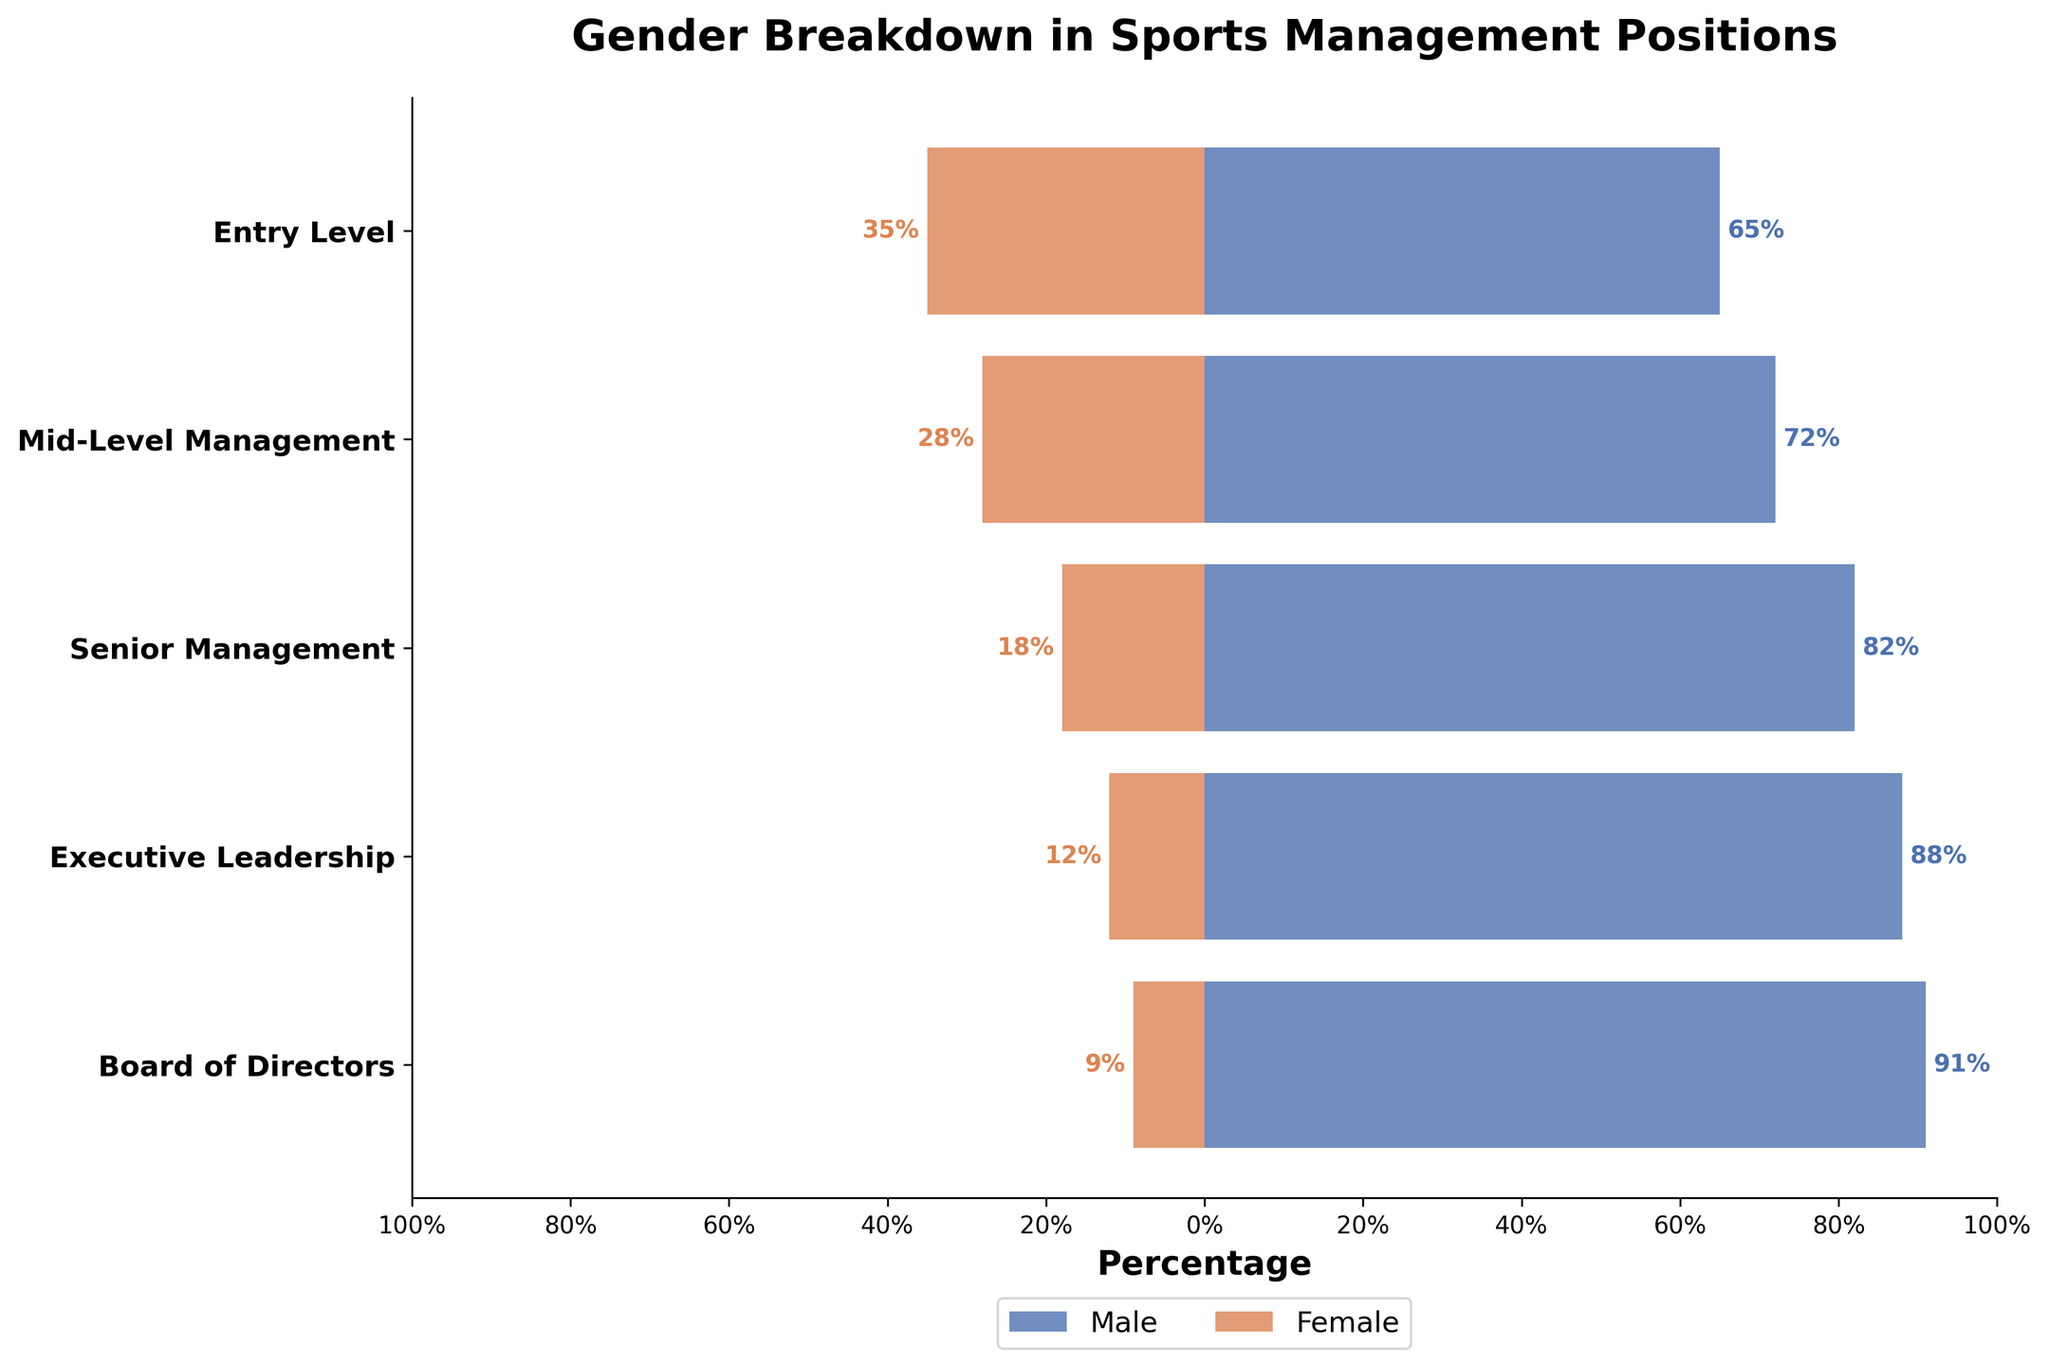what is the title of the plot? The title is usually located at the top of the plot and generally describes what the figure is about. Here, it states the theme of the plot clearly.
Answer: Gender Breakdown in Sports Management Positions what is the percentage of males in entry-level positions? This can be found by looking at the bar corresponding to the Entry Level tier, on the male side.
Answer: 65% how does the percentage of females in senior management compare to that in mid-level management? Look at the female bars for both Mid-Level Management (28%) and Senior Management (18%). Compare the two percentages.
Answer: Lower by 10% what is the percentage difference between males and females in executive leadership positions? From the Executive Leadership tier, male percentage is 88% and female percentage is 12%. The difference between them is 88% - 12%.
Answer: 76% how many tiers are displayed in the plot? Count the number of unique y-ticks or categories along the vertical axis.
Answer: 5 which tier has the smallest representation for females? Compare the lengths of the female bars across all tiers to find the shortest one.
Answer: Board of Directors what is the combined percentage of males in mid-level and senior management positions? Add the percentages of males in Mid-Level Management (72%) and Senior Management (82%).
Answer: 154% what is the average percentage of females across all tiers? Sum the percentages of females in each tier: (35 + 28 + 18 + 12 + 9) = 102, then divide by the number of tiers (5).
Answer: 20.4% in which tier is the gender gap the widest? Calculate the absolute difference between male and female percentages in each tier and identify the tier with the largest difference (e.g., Executive Leadership tier: 88% - 12% = 76%).
Answer: Executive Leadership which gender is more prevalent at every tier? By observing the longer bar for each tier, determine which gender has a higher representation in each tier.
Answer: Male 